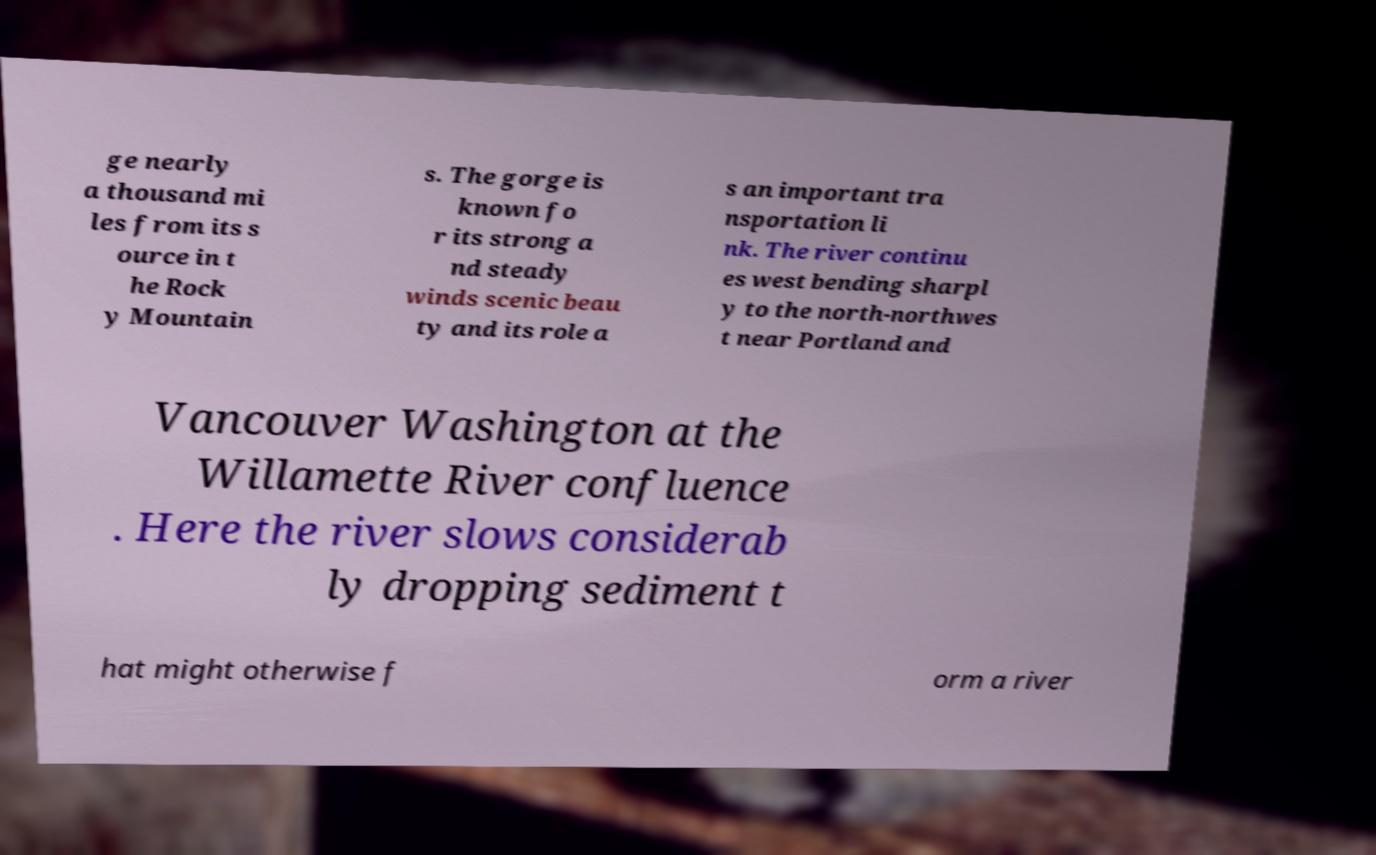There's text embedded in this image that I need extracted. Can you transcribe it verbatim? ge nearly a thousand mi les from its s ource in t he Rock y Mountain s. The gorge is known fo r its strong a nd steady winds scenic beau ty and its role a s an important tra nsportation li nk. The river continu es west bending sharpl y to the north-northwes t near Portland and Vancouver Washington at the Willamette River confluence . Here the river slows considerab ly dropping sediment t hat might otherwise f orm a river 